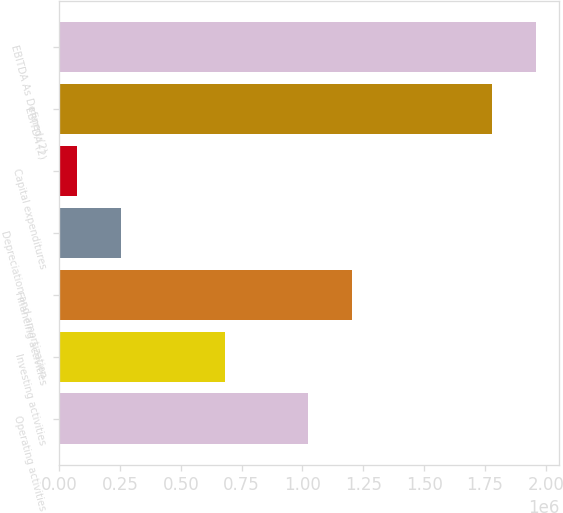Convert chart to OTSL. <chart><loc_0><loc_0><loc_500><loc_500><bar_chart><fcel>Operating activities<fcel>Investing activities<fcel>Financing activities<fcel>Depreciation and amortization<fcel>Capital expenditures<fcel>EBITDA (2)<fcel>EBITDA As Defined (2)<nl><fcel>1.02217e+06<fcel>683577<fcel>1.20249e+06<fcel>253663<fcel>73341<fcel>1.77841e+06<fcel>1.95873e+06<nl></chart> 